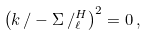<formula> <loc_0><loc_0><loc_500><loc_500>\left ( k \, / - \Sigma \, / _ { \ell } ^ { H } \right ) ^ { 2 } = 0 \, ,</formula> 